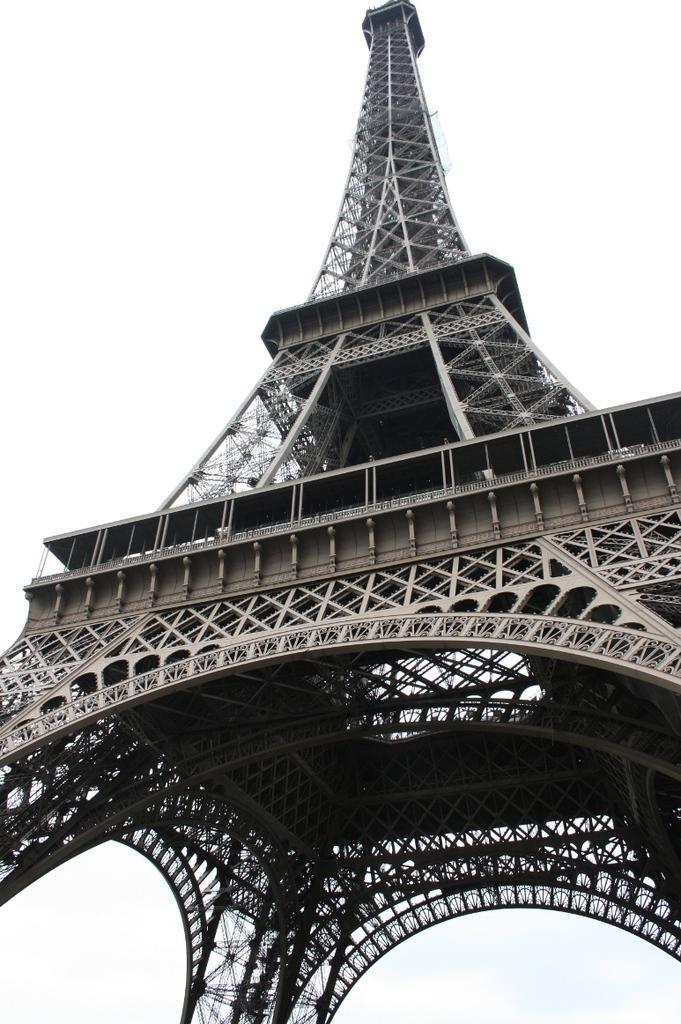Describe this image in one or two sentences. In this image there is a picture of a Eiffel tower. 